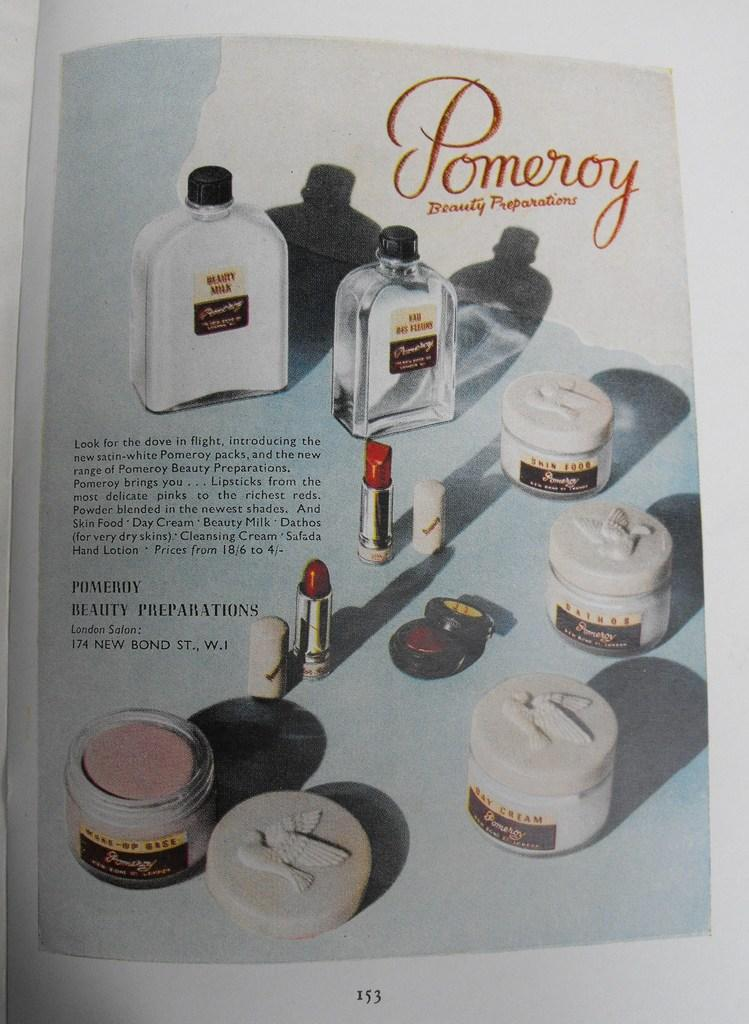<image>
Summarize the visual content of the image. An advertisement in a magazine for Pomeroy Beauty Preparations.. 